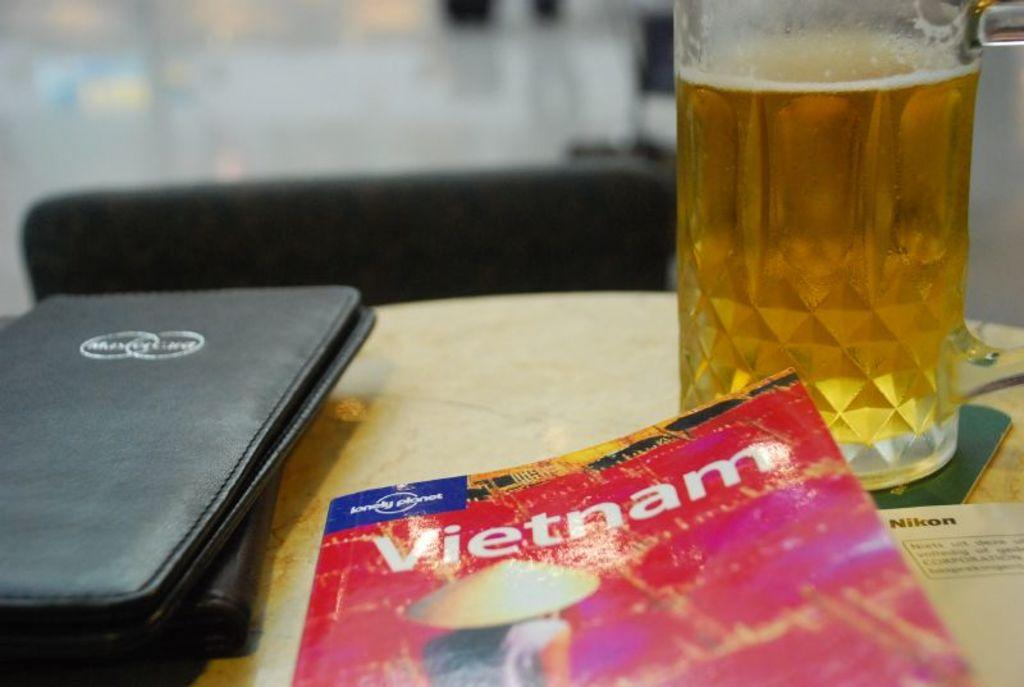Provide a one-sentence caption for the provided image. A table with a glass of beer,a receipt folder and a Vietnam book. 